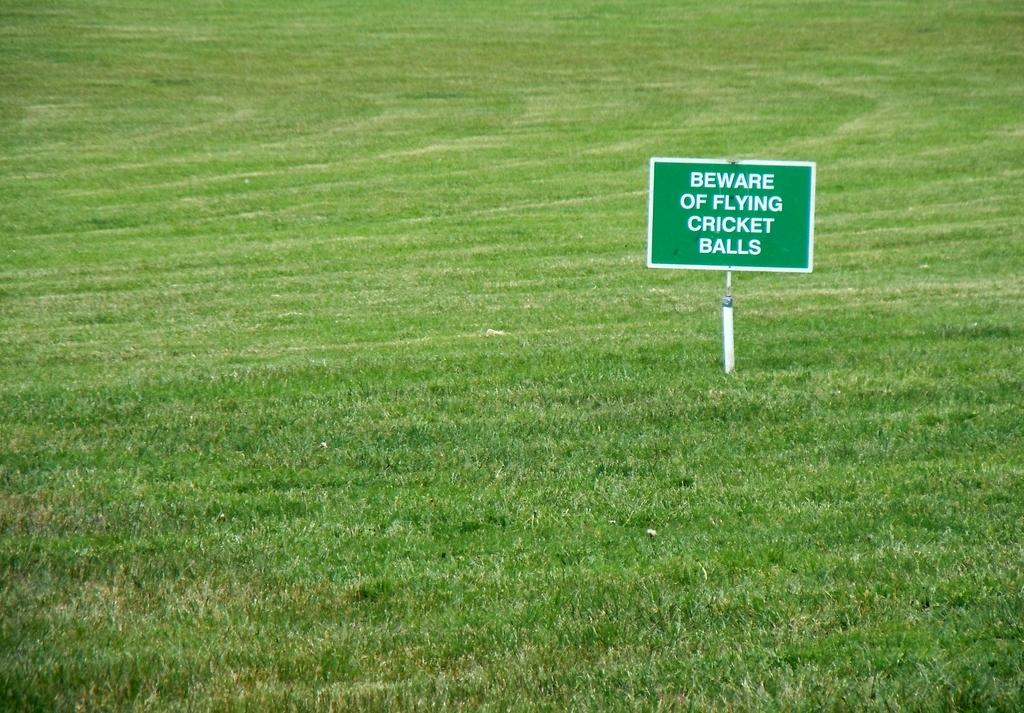What type of surface is visible in the foreground of the image? There is grass in the foreground of the image. What object is also present in the foreground of the image? There is a board with text in the foreground of the image. What message is written on the board? The text on the board says "BEWARE OF FLYING CRICKET BALLS". What type of animals can be seen in the zoo area of the image? There is no zoo present in the image, so it is not possible to determine what animals might be seen. 